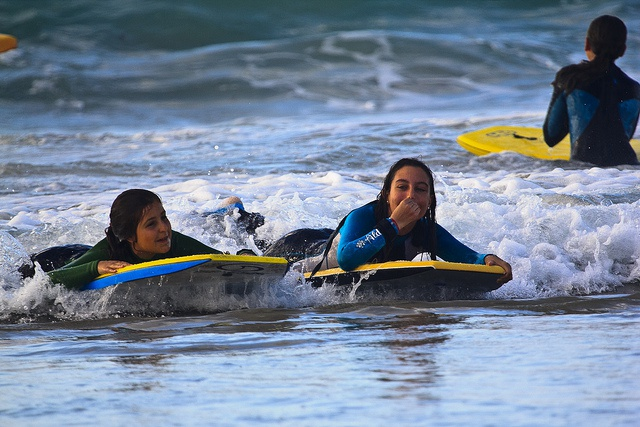Describe the objects in this image and their specific colors. I can see people in darkblue, black, navy, gray, and lightgray tones, people in darkblue, black, navy, blue, and gray tones, people in darkblue, black, maroon, and gray tones, surfboard in darkblue, black, orange, olive, and gray tones, and surfboard in darkblue, black, blue, gray, and olive tones in this image. 